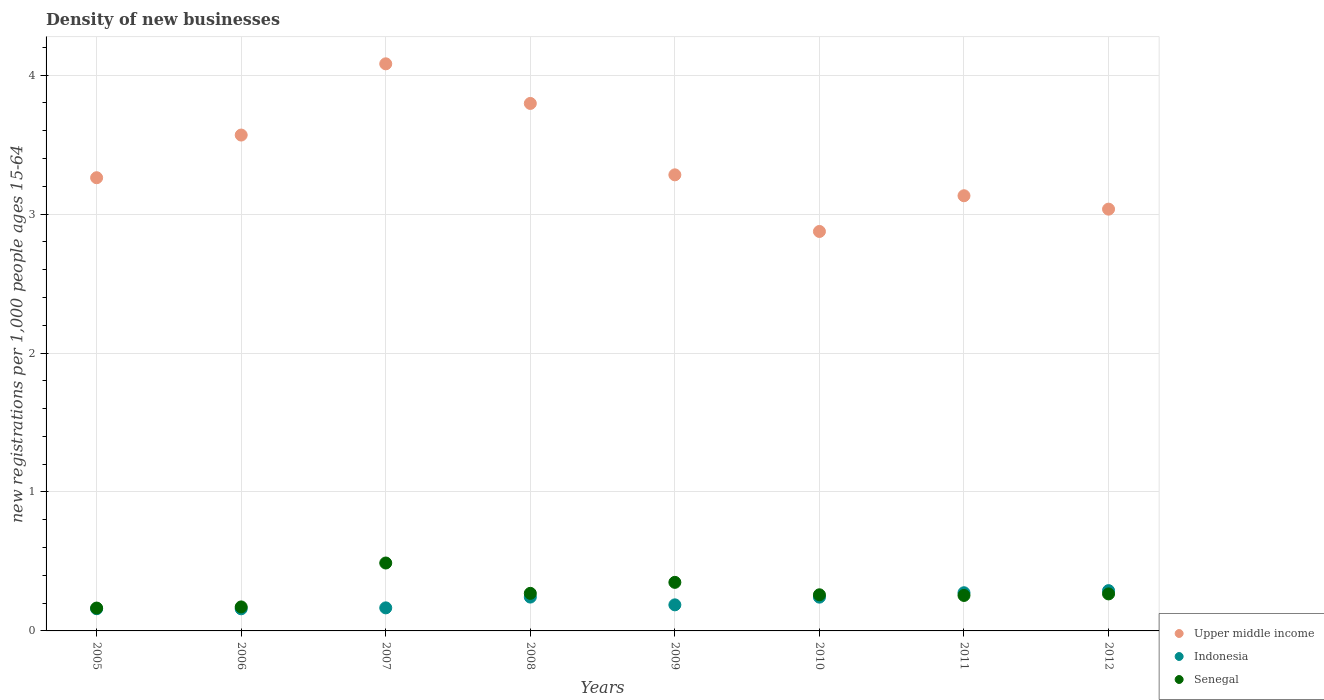How many different coloured dotlines are there?
Offer a very short reply. 3. What is the number of new registrations in Senegal in 2011?
Your response must be concise. 0.26. Across all years, what is the maximum number of new registrations in Senegal?
Ensure brevity in your answer.  0.49. Across all years, what is the minimum number of new registrations in Indonesia?
Provide a short and direct response. 0.16. In which year was the number of new registrations in Upper middle income maximum?
Offer a very short reply. 2007. In which year was the number of new registrations in Indonesia minimum?
Your response must be concise. 2006. What is the total number of new registrations in Senegal in the graph?
Your answer should be very brief. 2.23. What is the difference between the number of new registrations in Indonesia in 2006 and that in 2008?
Keep it short and to the point. -0.08. What is the difference between the number of new registrations in Indonesia in 2006 and the number of new registrations in Upper middle income in 2011?
Offer a very short reply. -2.97. What is the average number of new registrations in Upper middle income per year?
Offer a terse response. 3.38. In the year 2011, what is the difference between the number of new registrations in Senegal and number of new registrations in Upper middle income?
Keep it short and to the point. -2.88. In how many years, is the number of new registrations in Senegal greater than 3.8?
Your answer should be compact. 0. What is the ratio of the number of new registrations in Indonesia in 2006 to that in 2011?
Provide a succinct answer. 0.58. What is the difference between the highest and the second highest number of new registrations in Upper middle income?
Offer a very short reply. 0.29. What is the difference between the highest and the lowest number of new registrations in Indonesia?
Provide a succinct answer. 0.13. In how many years, is the number of new registrations in Upper middle income greater than the average number of new registrations in Upper middle income taken over all years?
Ensure brevity in your answer.  3. Is it the case that in every year, the sum of the number of new registrations in Senegal and number of new registrations in Indonesia  is greater than the number of new registrations in Upper middle income?
Offer a very short reply. No. Is the number of new registrations in Upper middle income strictly greater than the number of new registrations in Senegal over the years?
Make the answer very short. Yes. Is the number of new registrations in Upper middle income strictly less than the number of new registrations in Senegal over the years?
Offer a very short reply. No. How many years are there in the graph?
Ensure brevity in your answer.  8. What is the difference between two consecutive major ticks on the Y-axis?
Ensure brevity in your answer.  1. Does the graph contain any zero values?
Your answer should be very brief. No. Where does the legend appear in the graph?
Offer a terse response. Bottom right. How many legend labels are there?
Your response must be concise. 3. What is the title of the graph?
Offer a very short reply. Density of new businesses. Does "East Asia (developing only)" appear as one of the legend labels in the graph?
Your answer should be compact. No. What is the label or title of the X-axis?
Provide a short and direct response. Years. What is the label or title of the Y-axis?
Your answer should be very brief. New registrations per 1,0 people ages 15-64. What is the new registrations per 1,000 people ages 15-64 in Upper middle income in 2005?
Ensure brevity in your answer.  3.26. What is the new registrations per 1,000 people ages 15-64 of Indonesia in 2005?
Keep it short and to the point. 0.16. What is the new registrations per 1,000 people ages 15-64 of Senegal in 2005?
Make the answer very short. 0.16. What is the new registrations per 1,000 people ages 15-64 of Upper middle income in 2006?
Your answer should be compact. 3.57. What is the new registrations per 1,000 people ages 15-64 of Indonesia in 2006?
Give a very brief answer. 0.16. What is the new registrations per 1,000 people ages 15-64 of Senegal in 2006?
Provide a succinct answer. 0.17. What is the new registrations per 1,000 people ages 15-64 of Upper middle income in 2007?
Your answer should be very brief. 4.08. What is the new registrations per 1,000 people ages 15-64 in Indonesia in 2007?
Your response must be concise. 0.17. What is the new registrations per 1,000 people ages 15-64 of Senegal in 2007?
Keep it short and to the point. 0.49. What is the new registrations per 1,000 people ages 15-64 of Upper middle income in 2008?
Ensure brevity in your answer.  3.8. What is the new registrations per 1,000 people ages 15-64 of Indonesia in 2008?
Provide a short and direct response. 0.24. What is the new registrations per 1,000 people ages 15-64 in Senegal in 2008?
Keep it short and to the point. 0.27. What is the new registrations per 1,000 people ages 15-64 in Upper middle income in 2009?
Give a very brief answer. 3.28. What is the new registrations per 1,000 people ages 15-64 in Indonesia in 2009?
Offer a terse response. 0.19. What is the new registrations per 1,000 people ages 15-64 of Senegal in 2009?
Offer a terse response. 0.35. What is the new registrations per 1,000 people ages 15-64 of Upper middle income in 2010?
Your answer should be compact. 2.87. What is the new registrations per 1,000 people ages 15-64 in Indonesia in 2010?
Give a very brief answer. 0.24. What is the new registrations per 1,000 people ages 15-64 in Senegal in 2010?
Offer a very short reply. 0.26. What is the new registrations per 1,000 people ages 15-64 in Upper middle income in 2011?
Provide a succinct answer. 3.13. What is the new registrations per 1,000 people ages 15-64 of Indonesia in 2011?
Your response must be concise. 0.27. What is the new registrations per 1,000 people ages 15-64 in Senegal in 2011?
Your response must be concise. 0.26. What is the new registrations per 1,000 people ages 15-64 of Upper middle income in 2012?
Make the answer very short. 3.04. What is the new registrations per 1,000 people ages 15-64 in Indonesia in 2012?
Provide a short and direct response. 0.29. What is the new registrations per 1,000 people ages 15-64 of Senegal in 2012?
Ensure brevity in your answer.  0.27. Across all years, what is the maximum new registrations per 1,000 people ages 15-64 in Upper middle income?
Make the answer very short. 4.08. Across all years, what is the maximum new registrations per 1,000 people ages 15-64 in Indonesia?
Your answer should be compact. 0.29. Across all years, what is the maximum new registrations per 1,000 people ages 15-64 of Senegal?
Offer a very short reply. 0.49. Across all years, what is the minimum new registrations per 1,000 people ages 15-64 in Upper middle income?
Keep it short and to the point. 2.87. Across all years, what is the minimum new registrations per 1,000 people ages 15-64 in Indonesia?
Your answer should be compact. 0.16. Across all years, what is the minimum new registrations per 1,000 people ages 15-64 of Senegal?
Your answer should be compact. 0.16. What is the total new registrations per 1,000 people ages 15-64 of Upper middle income in the graph?
Provide a short and direct response. 27.03. What is the total new registrations per 1,000 people ages 15-64 of Indonesia in the graph?
Your answer should be compact. 1.72. What is the total new registrations per 1,000 people ages 15-64 of Senegal in the graph?
Give a very brief answer. 2.23. What is the difference between the new registrations per 1,000 people ages 15-64 of Upper middle income in 2005 and that in 2006?
Make the answer very short. -0.31. What is the difference between the new registrations per 1,000 people ages 15-64 in Senegal in 2005 and that in 2006?
Give a very brief answer. -0.01. What is the difference between the new registrations per 1,000 people ages 15-64 in Upper middle income in 2005 and that in 2007?
Keep it short and to the point. -0.82. What is the difference between the new registrations per 1,000 people ages 15-64 in Indonesia in 2005 and that in 2007?
Your answer should be very brief. -0.01. What is the difference between the new registrations per 1,000 people ages 15-64 in Senegal in 2005 and that in 2007?
Ensure brevity in your answer.  -0.32. What is the difference between the new registrations per 1,000 people ages 15-64 of Upper middle income in 2005 and that in 2008?
Provide a short and direct response. -0.53. What is the difference between the new registrations per 1,000 people ages 15-64 in Indonesia in 2005 and that in 2008?
Provide a short and direct response. -0.08. What is the difference between the new registrations per 1,000 people ages 15-64 of Senegal in 2005 and that in 2008?
Ensure brevity in your answer.  -0.11. What is the difference between the new registrations per 1,000 people ages 15-64 in Upper middle income in 2005 and that in 2009?
Provide a succinct answer. -0.02. What is the difference between the new registrations per 1,000 people ages 15-64 of Indonesia in 2005 and that in 2009?
Your answer should be very brief. -0.03. What is the difference between the new registrations per 1,000 people ages 15-64 in Senegal in 2005 and that in 2009?
Your answer should be very brief. -0.18. What is the difference between the new registrations per 1,000 people ages 15-64 in Upper middle income in 2005 and that in 2010?
Offer a very short reply. 0.39. What is the difference between the new registrations per 1,000 people ages 15-64 of Indonesia in 2005 and that in 2010?
Your answer should be very brief. -0.08. What is the difference between the new registrations per 1,000 people ages 15-64 of Senegal in 2005 and that in 2010?
Provide a succinct answer. -0.1. What is the difference between the new registrations per 1,000 people ages 15-64 of Upper middle income in 2005 and that in 2011?
Your response must be concise. 0.13. What is the difference between the new registrations per 1,000 people ages 15-64 in Indonesia in 2005 and that in 2011?
Offer a terse response. -0.12. What is the difference between the new registrations per 1,000 people ages 15-64 of Senegal in 2005 and that in 2011?
Make the answer very short. -0.09. What is the difference between the new registrations per 1,000 people ages 15-64 in Upper middle income in 2005 and that in 2012?
Your answer should be very brief. 0.23. What is the difference between the new registrations per 1,000 people ages 15-64 in Indonesia in 2005 and that in 2012?
Offer a terse response. -0.13. What is the difference between the new registrations per 1,000 people ages 15-64 in Senegal in 2005 and that in 2012?
Offer a very short reply. -0.1. What is the difference between the new registrations per 1,000 people ages 15-64 of Upper middle income in 2006 and that in 2007?
Your answer should be compact. -0.51. What is the difference between the new registrations per 1,000 people ages 15-64 of Indonesia in 2006 and that in 2007?
Offer a terse response. -0.01. What is the difference between the new registrations per 1,000 people ages 15-64 of Senegal in 2006 and that in 2007?
Make the answer very short. -0.32. What is the difference between the new registrations per 1,000 people ages 15-64 in Upper middle income in 2006 and that in 2008?
Offer a terse response. -0.23. What is the difference between the new registrations per 1,000 people ages 15-64 of Indonesia in 2006 and that in 2008?
Provide a short and direct response. -0.08. What is the difference between the new registrations per 1,000 people ages 15-64 in Senegal in 2006 and that in 2008?
Give a very brief answer. -0.1. What is the difference between the new registrations per 1,000 people ages 15-64 in Upper middle income in 2006 and that in 2009?
Give a very brief answer. 0.29. What is the difference between the new registrations per 1,000 people ages 15-64 of Indonesia in 2006 and that in 2009?
Ensure brevity in your answer.  -0.03. What is the difference between the new registrations per 1,000 people ages 15-64 of Senegal in 2006 and that in 2009?
Provide a short and direct response. -0.18. What is the difference between the new registrations per 1,000 people ages 15-64 of Upper middle income in 2006 and that in 2010?
Your answer should be very brief. 0.69. What is the difference between the new registrations per 1,000 people ages 15-64 of Indonesia in 2006 and that in 2010?
Offer a terse response. -0.08. What is the difference between the new registrations per 1,000 people ages 15-64 of Senegal in 2006 and that in 2010?
Your answer should be compact. -0.09. What is the difference between the new registrations per 1,000 people ages 15-64 of Upper middle income in 2006 and that in 2011?
Provide a short and direct response. 0.44. What is the difference between the new registrations per 1,000 people ages 15-64 of Indonesia in 2006 and that in 2011?
Your response must be concise. -0.12. What is the difference between the new registrations per 1,000 people ages 15-64 in Senegal in 2006 and that in 2011?
Ensure brevity in your answer.  -0.08. What is the difference between the new registrations per 1,000 people ages 15-64 in Upper middle income in 2006 and that in 2012?
Offer a very short reply. 0.53. What is the difference between the new registrations per 1,000 people ages 15-64 in Indonesia in 2006 and that in 2012?
Make the answer very short. -0.13. What is the difference between the new registrations per 1,000 people ages 15-64 in Senegal in 2006 and that in 2012?
Provide a short and direct response. -0.09. What is the difference between the new registrations per 1,000 people ages 15-64 of Upper middle income in 2007 and that in 2008?
Ensure brevity in your answer.  0.29. What is the difference between the new registrations per 1,000 people ages 15-64 in Indonesia in 2007 and that in 2008?
Offer a very short reply. -0.08. What is the difference between the new registrations per 1,000 people ages 15-64 of Senegal in 2007 and that in 2008?
Ensure brevity in your answer.  0.22. What is the difference between the new registrations per 1,000 people ages 15-64 in Upper middle income in 2007 and that in 2009?
Your response must be concise. 0.8. What is the difference between the new registrations per 1,000 people ages 15-64 in Indonesia in 2007 and that in 2009?
Offer a very short reply. -0.02. What is the difference between the new registrations per 1,000 people ages 15-64 of Senegal in 2007 and that in 2009?
Offer a very short reply. 0.14. What is the difference between the new registrations per 1,000 people ages 15-64 of Upper middle income in 2007 and that in 2010?
Provide a short and direct response. 1.21. What is the difference between the new registrations per 1,000 people ages 15-64 in Indonesia in 2007 and that in 2010?
Provide a short and direct response. -0.08. What is the difference between the new registrations per 1,000 people ages 15-64 of Senegal in 2007 and that in 2010?
Keep it short and to the point. 0.23. What is the difference between the new registrations per 1,000 people ages 15-64 in Upper middle income in 2007 and that in 2011?
Your answer should be compact. 0.95. What is the difference between the new registrations per 1,000 people ages 15-64 of Indonesia in 2007 and that in 2011?
Ensure brevity in your answer.  -0.11. What is the difference between the new registrations per 1,000 people ages 15-64 in Senegal in 2007 and that in 2011?
Offer a very short reply. 0.23. What is the difference between the new registrations per 1,000 people ages 15-64 in Upper middle income in 2007 and that in 2012?
Give a very brief answer. 1.05. What is the difference between the new registrations per 1,000 people ages 15-64 in Indonesia in 2007 and that in 2012?
Your answer should be very brief. -0.12. What is the difference between the new registrations per 1,000 people ages 15-64 in Senegal in 2007 and that in 2012?
Keep it short and to the point. 0.22. What is the difference between the new registrations per 1,000 people ages 15-64 of Upper middle income in 2008 and that in 2009?
Ensure brevity in your answer.  0.51. What is the difference between the new registrations per 1,000 people ages 15-64 in Indonesia in 2008 and that in 2009?
Make the answer very short. 0.06. What is the difference between the new registrations per 1,000 people ages 15-64 of Senegal in 2008 and that in 2009?
Offer a terse response. -0.08. What is the difference between the new registrations per 1,000 people ages 15-64 in Upper middle income in 2008 and that in 2010?
Keep it short and to the point. 0.92. What is the difference between the new registrations per 1,000 people ages 15-64 in Senegal in 2008 and that in 2010?
Keep it short and to the point. 0.01. What is the difference between the new registrations per 1,000 people ages 15-64 of Upper middle income in 2008 and that in 2011?
Your answer should be very brief. 0.66. What is the difference between the new registrations per 1,000 people ages 15-64 in Indonesia in 2008 and that in 2011?
Give a very brief answer. -0.03. What is the difference between the new registrations per 1,000 people ages 15-64 of Senegal in 2008 and that in 2011?
Offer a terse response. 0.01. What is the difference between the new registrations per 1,000 people ages 15-64 in Upper middle income in 2008 and that in 2012?
Give a very brief answer. 0.76. What is the difference between the new registrations per 1,000 people ages 15-64 of Indonesia in 2008 and that in 2012?
Make the answer very short. -0.05. What is the difference between the new registrations per 1,000 people ages 15-64 in Senegal in 2008 and that in 2012?
Make the answer very short. 0. What is the difference between the new registrations per 1,000 people ages 15-64 of Upper middle income in 2009 and that in 2010?
Your answer should be compact. 0.41. What is the difference between the new registrations per 1,000 people ages 15-64 in Indonesia in 2009 and that in 2010?
Offer a very short reply. -0.06. What is the difference between the new registrations per 1,000 people ages 15-64 in Senegal in 2009 and that in 2010?
Ensure brevity in your answer.  0.09. What is the difference between the new registrations per 1,000 people ages 15-64 in Upper middle income in 2009 and that in 2011?
Make the answer very short. 0.15. What is the difference between the new registrations per 1,000 people ages 15-64 of Indonesia in 2009 and that in 2011?
Provide a short and direct response. -0.09. What is the difference between the new registrations per 1,000 people ages 15-64 of Senegal in 2009 and that in 2011?
Provide a succinct answer. 0.09. What is the difference between the new registrations per 1,000 people ages 15-64 of Upper middle income in 2009 and that in 2012?
Make the answer very short. 0.25. What is the difference between the new registrations per 1,000 people ages 15-64 of Indonesia in 2009 and that in 2012?
Make the answer very short. -0.1. What is the difference between the new registrations per 1,000 people ages 15-64 of Senegal in 2009 and that in 2012?
Give a very brief answer. 0.08. What is the difference between the new registrations per 1,000 people ages 15-64 of Upper middle income in 2010 and that in 2011?
Give a very brief answer. -0.26. What is the difference between the new registrations per 1,000 people ages 15-64 of Indonesia in 2010 and that in 2011?
Your answer should be compact. -0.03. What is the difference between the new registrations per 1,000 people ages 15-64 in Senegal in 2010 and that in 2011?
Make the answer very short. 0. What is the difference between the new registrations per 1,000 people ages 15-64 in Upper middle income in 2010 and that in 2012?
Offer a very short reply. -0.16. What is the difference between the new registrations per 1,000 people ages 15-64 in Indonesia in 2010 and that in 2012?
Offer a very short reply. -0.05. What is the difference between the new registrations per 1,000 people ages 15-64 in Senegal in 2010 and that in 2012?
Keep it short and to the point. -0.01. What is the difference between the new registrations per 1,000 people ages 15-64 in Upper middle income in 2011 and that in 2012?
Your answer should be very brief. 0.1. What is the difference between the new registrations per 1,000 people ages 15-64 in Indonesia in 2011 and that in 2012?
Provide a short and direct response. -0.02. What is the difference between the new registrations per 1,000 people ages 15-64 of Senegal in 2011 and that in 2012?
Your response must be concise. -0.01. What is the difference between the new registrations per 1,000 people ages 15-64 of Upper middle income in 2005 and the new registrations per 1,000 people ages 15-64 of Indonesia in 2006?
Give a very brief answer. 3.1. What is the difference between the new registrations per 1,000 people ages 15-64 in Upper middle income in 2005 and the new registrations per 1,000 people ages 15-64 in Senegal in 2006?
Offer a very short reply. 3.09. What is the difference between the new registrations per 1,000 people ages 15-64 of Indonesia in 2005 and the new registrations per 1,000 people ages 15-64 of Senegal in 2006?
Your answer should be compact. -0.01. What is the difference between the new registrations per 1,000 people ages 15-64 of Upper middle income in 2005 and the new registrations per 1,000 people ages 15-64 of Indonesia in 2007?
Offer a very short reply. 3.1. What is the difference between the new registrations per 1,000 people ages 15-64 in Upper middle income in 2005 and the new registrations per 1,000 people ages 15-64 in Senegal in 2007?
Give a very brief answer. 2.77. What is the difference between the new registrations per 1,000 people ages 15-64 in Indonesia in 2005 and the new registrations per 1,000 people ages 15-64 in Senegal in 2007?
Provide a succinct answer. -0.33. What is the difference between the new registrations per 1,000 people ages 15-64 in Upper middle income in 2005 and the new registrations per 1,000 people ages 15-64 in Indonesia in 2008?
Your answer should be compact. 3.02. What is the difference between the new registrations per 1,000 people ages 15-64 in Upper middle income in 2005 and the new registrations per 1,000 people ages 15-64 in Senegal in 2008?
Ensure brevity in your answer.  2.99. What is the difference between the new registrations per 1,000 people ages 15-64 in Indonesia in 2005 and the new registrations per 1,000 people ages 15-64 in Senegal in 2008?
Offer a terse response. -0.11. What is the difference between the new registrations per 1,000 people ages 15-64 in Upper middle income in 2005 and the new registrations per 1,000 people ages 15-64 in Indonesia in 2009?
Your answer should be compact. 3.07. What is the difference between the new registrations per 1,000 people ages 15-64 of Upper middle income in 2005 and the new registrations per 1,000 people ages 15-64 of Senegal in 2009?
Your answer should be compact. 2.91. What is the difference between the new registrations per 1,000 people ages 15-64 of Indonesia in 2005 and the new registrations per 1,000 people ages 15-64 of Senegal in 2009?
Your answer should be very brief. -0.19. What is the difference between the new registrations per 1,000 people ages 15-64 in Upper middle income in 2005 and the new registrations per 1,000 people ages 15-64 in Indonesia in 2010?
Provide a succinct answer. 3.02. What is the difference between the new registrations per 1,000 people ages 15-64 in Upper middle income in 2005 and the new registrations per 1,000 people ages 15-64 in Senegal in 2010?
Provide a short and direct response. 3. What is the difference between the new registrations per 1,000 people ages 15-64 of Indonesia in 2005 and the new registrations per 1,000 people ages 15-64 of Senegal in 2010?
Make the answer very short. -0.1. What is the difference between the new registrations per 1,000 people ages 15-64 in Upper middle income in 2005 and the new registrations per 1,000 people ages 15-64 in Indonesia in 2011?
Offer a terse response. 2.99. What is the difference between the new registrations per 1,000 people ages 15-64 in Upper middle income in 2005 and the new registrations per 1,000 people ages 15-64 in Senegal in 2011?
Provide a succinct answer. 3.01. What is the difference between the new registrations per 1,000 people ages 15-64 in Indonesia in 2005 and the new registrations per 1,000 people ages 15-64 in Senegal in 2011?
Provide a succinct answer. -0.1. What is the difference between the new registrations per 1,000 people ages 15-64 in Upper middle income in 2005 and the new registrations per 1,000 people ages 15-64 in Indonesia in 2012?
Your answer should be very brief. 2.97. What is the difference between the new registrations per 1,000 people ages 15-64 of Upper middle income in 2005 and the new registrations per 1,000 people ages 15-64 of Senegal in 2012?
Provide a short and direct response. 3. What is the difference between the new registrations per 1,000 people ages 15-64 in Indonesia in 2005 and the new registrations per 1,000 people ages 15-64 in Senegal in 2012?
Ensure brevity in your answer.  -0.11. What is the difference between the new registrations per 1,000 people ages 15-64 of Upper middle income in 2006 and the new registrations per 1,000 people ages 15-64 of Indonesia in 2007?
Your response must be concise. 3.4. What is the difference between the new registrations per 1,000 people ages 15-64 of Upper middle income in 2006 and the new registrations per 1,000 people ages 15-64 of Senegal in 2007?
Provide a succinct answer. 3.08. What is the difference between the new registrations per 1,000 people ages 15-64 of Indonesia in 2006 and the new registrations per 1,000 people ages 15-64 of Senegal in 2007?
Provide a succinct answer. -0.33. What is the difference between the new registrations per 1,000 people ages 15-64 in Upper middle income in 2006 and the new registrations per 1,000 people ages 15-64 in Indonesia in 2008?
Your response must be concise. 3.33. What is the difference between the new registrations per 1,000 people ages 15-64 in Upper middle income in 2006 and the new registrations per 1,000 people ages 15-64 in Senegal in 2008?
Provide a succinct answer. 3.3. What is the difference between the new registrations per 1,000 people ages 15-64 of Indonesia in 2006 and the new registrations per 1,000 people ages 15-64 of Senegal in 2008?
Provide a succinct answer. -0.11. What is the difference between the new registrations per 1,000 people ages 15-64 in Upper middle income in 2006 and the new registrations per 1,000 people ages 15-64 in Indonesia in 2009?
Make the answer very short. 3.38. What is the difference between the new registrations per 1,000 people ages 15-64 in Upper middle income in 2006 and the new registrations per 1,000 people ages 15-64 in Senegal in 2009?
Keep it short and to the point. 3.22. What is the difference between the new registrations per 1,000 people ages 15-64 in Indonesia in 2006 and the new registrations per 1,000 people ages 15-64 in Senegal in 2009?
Make the answer very short. -0.19. What is the difference between the new registrations per 1,000 people ages 15-64 in Upper middle income in 2006 and the new registrations per 1,000 people ages 15-64 in Indonesia in 2010?
Your response must be concise. 3.33. What is the difference between the new registrations per 1,000 people ages 15-64 in Upper middle income in 2006 and the new registrations per 1,000 people ages 15-64 in Senegal in 2010?
Your answer should be compact. 3.31. What is the difference between the new registrations per 1,000 people ages 15-64 of Indonesia in 2006 and the new registrations per 1,000 people ages 15-64 of Senegal in 2010?
Provide a short and direct response. -0.1. What is the difference between the new registrations per 1,000 people ages 15-64 in Upper middle income in 2006 and the new registrations per 1,000 people ages 15-64 in Indonesia in 2011?
Offer a very short reply. 3.29. What is the difference between the new registrations per 1,000 people ages 15-64 of Upper middle income in 2006 and the new registrations per 1,000 people ages 15-64 of Senegal in 2011?
Your response must be concise. 3.31. What is the difference between the new registrations per 1,000 people ages 15-64 of Indonesia in 2006 and the new registrations per 1,000 people ages 15-64 of Senegal in 2011?
Provide a succinct answer. -0.1. What is the difference between the new registrations per 1,000 people ages 15-64 in Upper middle income in 2006 and the new registrations per 1,000 people ages 15-64 in Indonesia in 2012?
Offer a very short reply. 3.28. What is the difference between the new registrations per 1,000 people ages 15-64 of Upper middle income in 2006 and the new registrations per 1,000 people ages 15-64 of Senegal in 2012?
Ensure brevity in your answer.  3.3. What is the difference between the new registrations per 1,000 people ages 15-64 of Indonesia in 2006 and the new registrations per 1,000 people ages 15-64 of Senegal in 2012?
Make the answer very short. -0.11. What is the difference between the new registrations per 1,000 people ages 15-64 of Upper middle income in 2007 and the new registrations per 1,000 people ages 15-64 of Indonesia in 2008?
Your answer should be compact. 3.84. What is the difference between the new registrations per 1,000 people ages 15-64 of Upper middle income in 2007 and the new registrations per 1,000 people ages 15-64 of Senegal in 2008?
Give a very brief answer. 3.81. What is the difference between the new registrations per 1,000 people ages 15-64 of Indonesia in 2007 and the new registrations per 1,000 people ages 15-64 of Senegal in 2008?
Offer a very short reply. -0.1. What is the difference between the new registrations per 1,000 people ages 15-64 in Upper middle income in 2007 and the new registrations per 1,000 people ages 15-64 in Indonesia in 2009?
Your answer should be compact. 3.89. What is the difference between the new registrations per 1,000 people ages 15-64 in Upper middle income in 2007 and the new registrations per 1,000 people ages 15-64 in Senegal in 2009?
Offer a terse response. 3.73. What is the difference between the new registrations per 1,000 people ages 15-64 in Indonesia in 2007 and the new registrations per 1,000 people ages 15-64 in Senegal in 2009?
Provide a succinct answer. -0.18. What is the difference between the new registrations per 1,000 people ages 15-64 in Upper middle income in 2007 and the new registrations per 1,000 people ages 15-64 in Indonesia in 2010?
Give a very brief answer. 3.84. What is the difference between the new registrations per 1,000 people ages 15-64 of Upper middle income in 2007 and the new registrations per 1,000 people ages 15-64 of Senegal in 2010?
Your response must be concise. 3.82. What is the difference between the new registrations per 1,000 people ages 15-64 of Indonesia in 2007 and the new registrations per 1,000 people ages 15-64 of Senegal in 2010?
Offer a terse response. -0.09. What is the difference between the new registrations per 1,000 people ages 15-64 of Upper middle income in 2007 and the new registrations per 1,000 people ages 15-64 of Indonesia in 2011?
Ensure brevity in your answer.  3.81. What is the difference between the new registrations per 1,000 people ages 15-64 of Upper middle income in 2007 and the new registrations per 1,000 people ages 15-64 of Senegal in 2011?
Give a very brief answer. 3.83. What is the difference between the new registrations per 1,000 people ages 15-64 of Indonesia in 2007 and the new registrations per 1,000 people ages 15-64 of Senegal in 2011?
Keep it short and to the point. -0.09. What is the difference between the new registrations per 1,000 people ages 15-64 of Upper middle income in 2007 and the new registrations per 1,000 people ages 15-64 of Indonesia in 2012?
Keep it short and to the point. 3.79. What is the difference between the new registrations per 1,000 people ages 15-64 in Upper middle income in 2007 and the new registrations per 1,000 people ages 15-64 in Senegal in 2012?
Your response must be concise. 3.81. What is the difference between the new registrations per 1,000 people ages 15-64 of Indonesia in 2007 and the new registrations per 1,000 people ages 15-64 of Senegal in 2012?
Ensure brevity in your answer.  -0.1. What is the difference between the new registrations per 1,000 people ages 15-64 of Upper middle income in 2008 and the new registrations per 1,000 people ages 15-64 of Indonesia in 2009?
Provide a succinct answer. 3.61. What is the difference between the new registrations per 1,000 people ages 15-64 in Upper middle income in 2008 and the new registrations per 1,000 people ages 15-64 in Senegal in 2009?
Keep it short and to the point. 3.45. What is the difference between the new registrations per 1,000 people ages 15-64 in Indonesia in 2008 and the new registrations per 1,000 people ages 15-64 in Senegal in 2009?
Provide a short and direct response. -0.11. What is the difference between the new registrations per 1,000 people ages 15-64 in Upper middle income in 2008 and the new registrations per 1,000 people ages 15-64 in Indonesia in 2010?
Your answer should be compact. 3.55. What is the difference between the new registrations per 1,000 people ages 15-64 of Upper middle income in 2008 and the new registrations per 1,000 people ages 15-64 of Senegal in 2010?
Keep it short and to the point. 3.54. What is the difference between the new registrations per 1,000 people ages 15-64 of Indonesia in 2008 and the new registrations per 1,000 people ages 15-64 of Senegal in 2010?
Make the answer very short. -0.02. What is the difference between the new registrations per 1,000 people ages 15-64 of Upper middle income in 2008 and the new registrations per 1,000 people ages 15-64 of Indonesia in 2011?
Ensure brevity in your answer.  3.52. What is the difference between the new registrations per 1,000 people ages 15-64 in Upper middle income in 2008 and the new registrations per 1,000 people ages 15-64 in Senegal in 2011?
Keep it short and to the point. 3.54. What is the difference between the new registrations per 1,000 people ages 15-64 of Indonesia in 2008 and the new registrations per 1,000 people ages 15-64 of Senegal in 2011?
Make the answer very short. -0.01. What is the difference between the new registrations per 1,000 people ages 15-64 of Upper middle income in 2008 and the new registrations per 1,000 people ages 15-64 of Indonesia in 2012?
Give a very brief answer. 3.51. What is the difference between the new registrations per 1,000 people ages 15-64 in Upper middle income in 2008 and the new registrations per 1,000 people ages 15-64 in Senegal in 2012?
Your answer should be compact. 3.53. What is the difference between the new registrations per 1,000 people ages 15-64 of Indonesia in 2008 and the new registrations per 1,000 people ages 15-64 of Senegal in 2012?
Offer a very short reply. -0.02. What is the difference between the new registrations per 1,000 people ages 15-64 of Upper middle income in 2009 and the new registrations per 1,000 people ages 15-64 of Indonesia in 2010?
Give a very brief answer. 3.04. What is the difference between the new registrations per 1,000 people ages 15-64 in Upper middle income in 2009 and the new registrations per 1,000 people ages 15-64 in Senegal in 2010?
Provide a short and direct response. 3.02. What is the difference between the new registrations per 1,000 people ages 15-64 in Indonesia in 2009 and the new registrations per 1,000 people ages 15-64 in Senegal in 2010?
Offer a very short reply. -0.07. What is the difference between the new registrations per 1,000 people ages 15-64 of Upper middle income in 2009 and the new registrations per 1,000 people ages 15-64 of Indonesia in 2011?
Make the answer very short. 3.01. What is the difference between the new registrations per 1,000 people ages 15-64 of Upper middle income in 2009 and the new registrations per 1,000 people ages 15-64 of Senegal in 2011?
Offer a very short reply. 3.03. What is the difference between the new registrations per 1,000 people ages 15-64 in Indonesia in 2009 and the new registrations per 1,000 people ages 15-64 in Senegal in 2011?
Ensure brevity in your answer.  -0.07. What is the difference between the new registrations per 1,000 people ages 15-64 in Upper middle income in 2009 and the new registrations per 1,000 people ages 15-64 in Indonesia in 2012?
Make the answer very short. 2.99. What is the difference between the new registrations per 1,000 people ages 15-64 in Upper middle income in 2009 and the new registrations per 1,000 people ages 15-64 in Senegal in 2012?
Give a very brief answer. 3.02. What is the difference between the new registrations per 1,000 people ages 15-64 in Indonesia in 2009 and the new registrations per 1,000 people ages 15-64 in Senegal in 2012?
Ensure brevity in your answer.  -0.08. What is the difference between the new registrations per 1,000 people ages 15-64 in Upper middle income in 2010 and the new registrations per 1,000 people ages 15-64 in Indonesia in 2011?
Offer a terse response. 2.6. What is the difference between the new registrations per 1,000 people ages 15-64 of Upper middle income in 2010 and the new registrations per 1,000 people ages 15-64 of Senegal in 2011?
Offer a terse response. 2.62. What is the difference between the new registrations per 1,000 people ages 15-64 of Indonesia in 2010 and the new registrations per 1,000 people ages 15-64 of Senegal in 2011?
Keep it short and to the point. -0.01. What is the difference between the new registrations per 1,000 people ages 15-64 in Upper middle income in 2010 and the new registrations per 1,000 people ages 15-64 in Indonesia in 2012?
Offer a terse response. 2.58. What is the difference between the new registrations per 1,000 people ages 15-64 of Upper middle income in 2010 and the new registrations per 1,000 people ages 15-64 of Senegal in 2012?
Your answer should be compact. 2.61. What is the difference between the new registrations per 1,000 people ages 15-64 in Indonesia in 2010 and the new registrations per 1,000 people ages 15-64 in Senegal in 2012?
Provide a succinct answer. -0.02. What is the difference between the new registrations per 1,000 people ages 15-64 in Upper middle income in 2011 and the new registrations per 1,000 people ages 15-64 in Indonesia in 2012?
Offer a very short reply. 2.84. What is the difference between the new registrations per 1,000 people ages 15-64 in Upper middle income in 2011 and the new registrations per 1,000 people ages 15-64 in Senegal in 2012?
Provide a succinct answer. 2.87. What is the difference between the new registrations per 1,000 people ages 15-64 of Indonesia in 2011 and the new registrations per 1,000 people ages 15-64 of Senegal in 2012?
Offer a very short reply. 0.01. What is the average new registrations per 1,000 people ages 15-64 in Upper middle income per year?
Offer a terse response. 3.38. What is the average new registrations per 1,000 people ages 15-64 in Indonesia per year?
Provide a succinct answer. 0.22. What is the average new registrations per 1,000 people ages 15-64 in Senegal per year?
Provide a succinct answer. 0.28. In the year 2005, what is the difference between the new registrations per 1,000 people ages 15-64 of Upper middle income and new registrations per 1,000 people ages 15-64 of Indonesia?
Your answer should be very brief. 3.1. In the year 2005, what is the difference between the new registrations per 1,000 people ages 15-64 in Upper middle income and new registrations per 1,000 people ages 15-64 in Senegal?
Offer a very short reply. 3.1. In the year 2005, what is the difference between the new registrations per 1,000 people ages 15-64 in Indonesia and new registrations per 1,000 people ages 15-64 in Senegal?
Offer a very short reply. -0. In the year 2006, what is the difference between the new registrations per 1,000 people ages 15-64 of Upper middle income and new registrations per 1,000 people ages 15-64 of Indonesia?
Offer a terse response. 3.41. In the year 2006, what is the difference between the new registrations per 1,000 people ages 15-64 in Upper middle income and new registrations per 1,000 people ages 15-64 in Senegal?
Make the answer very short. 3.4. In the year 2006, what is the difference between the new registrations per 1,000 people ages 15-64 in Indonesia and new registrations per 1,000 people ages 15-64 in Senegal?
Offer a terse response. -0.01. In the year 2007, what is the difference between the new registrations per 1,000 people ages 15-64 in Upper middle income and new registrations per 1,000 people ages 15-64 in Indonesia?
Offer a terse response. 3.92. In the year 2007, what is the difference between the new registrations per 1,000 people ages 15-64 in Upper middle income and new registrations per 1,000 people ages 15-64 in Senegal?
Provide a succinct answer. 3.59. In the year 2007, what is the difference between the new registrations per 1,000 people ages 15-64 in Indonesia and new registrations per 1,000 people ages 15-64 in Senegal?
Your answer should be very brief. -0.32. In the year 2008, what is the difference between the new registrations per 1,000 people ages 15-64 in Upper middle income and new registrations per 1,000 people ages 15-64 in Indonesia?
Your response must be concise. 3.55. In the year 2008, what is the difference between the new registrations per 1,000 people ages 15-64 in Upper middle income and new registrations per 1,000 people ages 15-64 in Senegal?
Provide a succinct answer. 3.53. In the year 2008, what is the difference between the new registrations per 1,000 people ages 15-64 of Indonesia and new registrations per 1,000 people ages 15-64 of Senegal?
Offer a very short reply. -0.03. In the year 2009, what is the difference between the new registrations per 1,000 people ages 15-64 of Upper middle income and new registrations per 1,000 people ages 15-64 of Indonesia?
Offer a terse response. 3.09. In the year 2009, what is the difference between the new registrations per 1,000 people ages 15-64 of Upper middle income and new registrations per 1,000 people ages 15-64 of Senegal?
Your answer should be very brief. 2.93. In the year 2009, what is the difference between the new registrations per 1,000 people ages 15-64 in Indonesia and new registrations per 1,000 people ages 15-64 in Senegal?
Give a very brief answer. -0.16. In the year 2010, what is the difference between the new registrations per 1,000 people ages 15-64 in Upper middle income and new registrations per 1,000 people ages 15-64 in Indonesia?
Your answer should be compact. 2.63. In the year 2010, what is the difference between the new registrations per 1,000 people ages 15-64 of Upper middle income and new registrations per 1,000 people ages 15-64 of Senegal?
Make the answer very short. 2.61. In the year 2010, what is the difference between the new registrations per 1,000 people ages 15-64 in Indonesia and new registrations per 1,000 people ages 15-64 in Senegal?
Keep it short and to the point. -0.02. In the year 2011, what is the difference between the new registrations per 1,000 people ages 15-64 in Upper middle income and new registrations per 1,000 people ages 15-64 in Indonesia?
Make the answer very short. 2.86. In the year 2011, what is the difference between the new registrations per 1,000 people ages 15-64 of Upper middle income and new registrations per 1,000 people ages 15-64 of Senegal?
Give a very brief answer. 2.88. In the year 2011, what is the difference between the new registrations per 1,000 people ages 15-64 in Indonesia and new registrations per 1,000 people ages 15-64 in Senegal?
Give a very brief answer. 0.02. In the year 2012, what is the difference between the new registrations per 1,000 people ages 15-64 in Upper middle income and new registrations per 1,000 people ages 15-64 in Indonesia?
Provide a short and direct response. 2.75. In the year 2012, what is the difference between the new registrations per 1,000 people ages 15-64 in Upper middle income and new registrations per 1,000 people ages 15-64 in Senegal?
Give a very brief answer. 2.77. In the year 2012, what is the difference between the new registrations per 1,000 people ages 15-64 of Indonesia and new registrations per 1,000 people ages 15-64 of Senegal?
Provide a succinct answer. 0.02. What is the ratio of the new registrations per 1,000 people ages 15-64 of Upper middle income in 2005 to that in 2006?
Keep it short and to the point. 0.91. What is the ratio of the new registrations per 1,000 people ages 15-64 in Indonesia in 2005 to that in 2006?
Provide a short and direct response. 1. What is the ratio of the new registrations per 1,000 people ages 15-64 of Senegal in 2005 to that in 2006?
Make the answer very short. 0.95. What is the ratio of the new registrations per 1,000 people ages 15-64 in Upper middle income in 2005 to that in 2007?
Provide a succinct answer. 0.8. What is the ratio of the new registrations per 1,000 people ages 15-64 of Indonesia in 2005 to that in 2007?
Offer a very short reply. 0.96. What is the ratio of the new registrations per 1,000 people ages 15-64 in Senegal in 2005 to that in 2007?
Your answer should be very brief. 0.34. What is the ratio of the new registrations per 1,000 people ages 15-64 of Upper middle income in 2005 to that in 2008?
Your answer should be very brief. 0.86. What is the ratio of the new registrations per 1,000 people ages 15-64 in Indonesia in 2005 to that in 2008?
Provide a succinct answer. 0.66. What is the ratio of the new registrations per 1,000 people ages 15-64 of Senegal in 2005 to that in 2008?
Your answer should be compact. 0.61. What is the ratio of the new registrations per 1,000 people ages 15-64 of Indonesia in 2005 to that in 2009?
Keep it short and to the point. 0.85. What is the ratio of the new registrations per 1,000 people ages 15-64 of Senegal in 2005 to that in 2009?
Keep it short and to the point. 0.47. What is the ratio of the new registrations per 1,000 people ages 15-64 of Upper middle income in 2005 to that in 2010?
Your answer should be compact. 1.13. What is the ratio of the new registrations per 1,000 people ages 15-64 in Indonesia in 2005 to that in 2010?
Offer a terse response. 0.66. What is the ratio of the new registrations per 1,000 people ages 15-64 in Senegal in 2005 to that in 2010?
Offer a very short reply. 0.63. What is the ratio of the new registrations per 1,000 people ages 15-64 in Upper middle income in 2005 to that in 2011?
Keep it short and to the point. 1.04. What is the ratio of the new registrations per 1,000 people ages 15-64 in Indonesia in 2005 to that in 2011?
Give a very brief answer. 0.58. What is the ratio of the new registrations per 1,000 people ages 15-64 in Senegal in 2005 to that in 2011?
Provide a short and direct response. 0.64. What is the ratio of the new registrations per 1,000 people ages 15-64 of Upper middle income in 2005 to that in 2012?
Ensure brevity in your answer.  1.07. What is the ratio of the new registrations per 1,000 people ages 15-64 in Indonesia in 2005 to that in 2012?
Provide a succinct answer. 0.55. What is the ratio of the new registrations per 1,000 people ages 15-64 in Senegal in 2005 to that in 2012?
Keep it short and to the point. 0.62. What is the ratio of the new registrations per 1,000 people ages 15-64 of Upper middle income in 2006 to that in 2007?
Offer a terse response. 0.87. What is the ratio of the new registrations per 1,000 people ages 15-64 of Indonesia in 2006 to that in 2007?
Make the answer very short. 0.96. What is the ratio of the new registrations per 1,000 people ages 15-64 in Senegal in 2006 to that in 2007?
Give a very brief answer. 0.35. What is the ratio of the new registrations per 1,000 people ages 15-64 in Upper middle income in 2006 to that in 2008?
Make the answer very short. 0.94. What is the ratio of the new registrations per 1,000 people ages 15-64 in Indonesia in 2006 to that in 2008?
Make the answer very short. 0.65. What is the ratio of the new registrations per 1,000 people ages 15-64 in Senegal in 2006 to that in 2008?
Give a very brief answer. 0.64. What is the ratio of the new registrations per 1,000 people ages 15-64 of Upper middle income in 2006 to that in 2009?
Make the answer very short. 1.09. What is the ratio of the new registrations per 1,000 people ages 15-64 of Indonesia in 2006 to that in 2009?
Offer a terse response. 0.85. What is the ratio of the new registrations per 1,000 people ages 15-64 in Senegal in 2006 to that in 2009?
Make the answer very short. 0.49. What is the ratio of the new registrations per 1,000 people ages 15-64 in Upper middle income in 2006 to that in 2010?
Provide a succinct answer. 1.24. What is the ratio of the new registrations per 1,000 people ages 15-64 in Indonesia in 2006 to that in 2010?
Your answer should be very brief. 0.65. What is the ratio of the new registrations per 1,000 people ages 15-64 of Senegal in 2006 to that in 2010?
Give a very brief answer. 0.66. What is the ratio of the new registrations per 1,000 people ages 15-64 of Upper middle income in 2006 to that in 2011?
Make the answer very short. 1.14. What is the ratio of the new registrations per 1,000 people ages 15-64 in Indonesia in 2006 to that in 2011?
Your answer should be very brief. 0.58. What is the ratio of the new registrations per 1,000 people ages 15-64 of Senegal in 2006 to that in 2011?
Provide a succinct answer. 0.68. What is the ratio of the new registrations per 1,000 people ages 15-64 in Upper middle income in 2006 to that in 2012?
Offer a very short reply. 1.18. What is the ratio of the new registrations per 1,000 people ages 15-64 of Indonesia in 2006 to that in 2012?
Your response must be concise. 0.55. What is the ratio of the new registrations per 1,000 people ages 15-64 in Senegal in 2006 to that in 2012?
Make the answer very short. 0.65. What is the ratio of the new registrations per 1,000 people ages 15-64 of Upper middle income in 2007 to that in 2008?
Provide a succinct answer. 1.08. What is the ratio of the new registrations per 1,000 people ages 15-64 in Indonesia in 2007 to that in 2008?
Provide a short and direct response. 0.68. What is the ratio of the new registrations per 1,000 people ages 15-64 in Senegal in 2007 to that in 2008?
Give a very brief answer. 1.81. What is the ratio of the new registrations per 1,000 people ages 15-64 in Upper middle income in 2007 to that in 2009?
Your answer should be very brief. 1.24. What is the ratio of the new registrations per 1,000 people ages 15-64 in Indonesia in 2007 to that in 2009?
Ensure brevity in your answer.  0.88. What is the ratio of the new registrations per 1,000 people ages 15-64 of Senegal in 2007 to that in 2009?
Keep it short and to the point. 1.4. What is the ratio of the new registrations per 1,000 people ages 15-64 in Upper middle income in 2007 to that in 2010?
Offer a very short reply. 1.42. What is the ratio of the new registrations per 1,000 people ages 15-64 of Indonesia in 2007 to that in 2010?
Provide a succinct answer. 0.68. What is the ratio of the new registrations per 1,000 people ages 15-64 in Senegal in 2007 to that in 2010?
Give a very brief answer. 1.88. What is the ratio of the new registrations per 1,000 people ages 15-64 in Upper middle income in 2007 to that in 2011?
Keep it short and to the point. 1.3. What is the ratio of the new registrations per 1,000 people ages 15-64 in Indonesia in 2007 to that in 2011?
Your answer should be compact. 0.6. What is the ratio of the new registrations per 1,000 people ages 15-64 in Senegal in 2007 to that in 2011?
Make the answer very short. 1.91. What is the ratio of the new registrations per 1,000 people ages 15-64 of Upper middle income in 2007 to that in 2012?
Offer a terse response. 1.34. What is the ratio of the new registrations per 1,000 people ages 15-64 in Indonesia in 2007 to that in 2012?
Give a very brief answer. 0.57. What is the ratio of the new registrations per 1,000 people ages 15-64 of Senegal in 2007 to that in 2012?
Give a very brief answer. 1.83. What is the ratio of the new registrations per 1,000 people ages 15-64 of Upper middle income in 2008 to that in 2009?
Your answer should be compact. 1.16. What is the ratio of the new registrations per 1,000 people ages 15-64 of Indonesia in 2008 to that in 2009?
Keep it short and to the point. 1.3. What is the ratio of the new registrations per 1,000 people ages 15-64 in Senegal in 2008 to that in 2009?
Provide a short and direct response. 0.77. What is the ratio of the new registrations per 1,000 people ages 15-64 of Upper middle income in 2008 to that in 2010?
Provide a short and direct response. 1.32. What is the ratio of the new registrations per 1,000 people ages 15-64 of Senegal in 2008 to that in 2010?
Offer a very short reply. 1.04. What is the ratio of the new registrations per 1,000 people ages 15-64 of Upper middle income in 2008 to that in 2011?
Provide a short and direct response. 1.21. What is the ratio of the new registrations per 1,000 people ages 15-64 of Indonesia in 2008 to that in 2011?
Provide a short and direct response. 0.89. What is the ratio of the new registrations per 1,000 people ages 15-64 in Senegal in 2008 to that in 2011?
Keep it short and to the point. 1.06. What is the ratio of the new registrations per 1,000 people ages 15-64 of Upper middle income in 2008 to that in 2012?
Offer a terse response. 1.25. What is the ratio of the new registrations per 1,000 people ages 15-64 in Indonesia in 2008 to that in 2012?
Provide a short and direct response. 0.84. What is the ratio of the new registrations per 1,000 people ages 15-64 in Senegal in 2008 to that in 2012?
Your response must be concise. 1.01. What is the ratio of the new registrations per 1,000 people ages 15-64 in Upper middle income in 2009 to that in 2010?
Make the answer very short. 1.14. What is the ratio of the new registrations per 1,000 people ages 15-64 of Indonesia in 2009 to that in 2010?
Your answer should be very brief. 0.77. What is the ratio of the new registrations per 1,000 people ages 15-64 of Senegal in 2009 to that in 2010?
Your response must be concise. 1.34. What is the ratio of the new registrations per 1,000 people ages 15-64 of Upper middle income in 2009 to that in 2011?
Offer a terse response. 1.05. What is the ratio of the new registrations per 1,000 people ages 15-64 in Indonesia in 2009 to that in 2011?
Offer a terse response. 0.68. What is the ratio of the new registrations per 1,000 people ages 15-64 in Senegal in 2009 to that in 2011?
Offer a terse response. 1.37. What is the ratio of the new registrations per 1,000 people ages 15-64 in Upper middle income in 2009 to that in 2012?
Offer a very short reply. 1.08. What is the ratio of the new registrations per 1,000 people ages 15-64 of Indonesia in 2009 to that in 2012?
Offer a very short reply. 0.65. What is the ratio of the new registrations per 1,000 people ages 15-64 in Senegal in 2009 to that in 2012?
Keep it short and to the point. 1.31. What is the ratio of the new registrations per 1,000 people ages 15-64 of Upper middle income in 2010 to that in 2011?
Keep it short and to the point. 0.92. What is the ratio of the new registrations per 1,000 people ages 15-64 of Indonesia in 2010 to that in 2011?
Offer a terse response. 0.88. What is the ratio of the new registrations per 1,000 people ages 15-64 of Senegal in 2010 to that in 2011?
Offer a very short reply. 1.02. What is the ratio of the new registrations per 1,000 people ages 15-64 in Upper middle income in 2010 to that in 2012?
Your answer should be very brief. 0.95. What is the ratio of the new registrations per 1,000 people ages 15-64 in Indonesia in 2010 to that in 2012?
Offer a terse response. 0.84. What is the ratio of the new registrations per 1,000 people ages 15-64 of Senegal in 2010 to that in 2012?
Give a very brief answer. 0.98. What is the ratio of the new registrations per 1,000 people ages 15-64 of Upper middle income in 2011 to that in 2012?
Offer a very short reply. 1.03. What is the ratio of the new registrations per 1,000 people ages 15-64 in Indonesia in 2011 to that in 2012?
Ensure brevity in your answer.  0.95. What is the ratio of the new registrations per 1,000 people ages 15-64 of Senegal in 2011 to that in 2012?
Make the answer very short. 0.96. What is the difference between the highest and the second highest new registrations per 1,000 people ages 15-64 of Upper middle income?
Offer a terse response. 0.29. What is the difference between the highest and the second highest new registrations per 1,000 people ages 15-64 of Indonesia?
Provide a succinct answer. 0.02. What is the difference between the highest and the second highest new registrations per 1,000 people ages 15-64 in Senegal?
Make the answer very short. 0.14. What is the difference between the highest and the lowest new registrations per 1,000 people ages 15-64 of Upper middle income?
Your response must be concise. 1.21. What is the difference between the highest and the lowest new registrations per 1,000 people ages 15-64 in Indonesia?
Your answer should be compact. 0.13. What is the difference between the highest and the lowest new registrations per 1,000 people ages 15-64 of Senegal?
Your answer should be very brief. 0.32. 